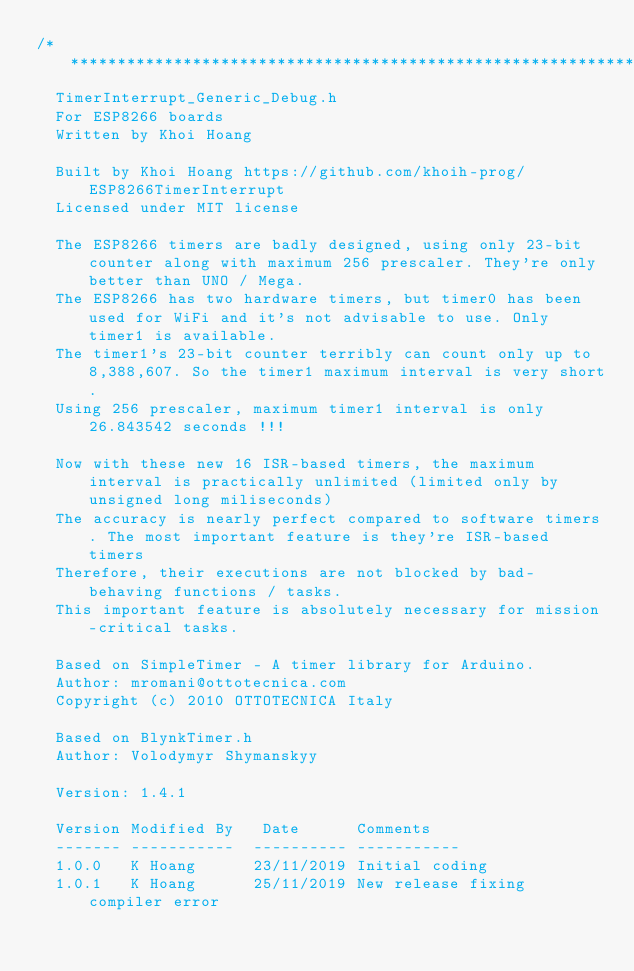Convert code to text. <code><loc_0><loc_0><loc_500><loc_500><_C_>/****************************************************************************************************************************
  TimerInterrupt_Generic_Debug.h
  For ESP8266 boards
  Written by Khoi Hoang

  Built by Khoi Hoang https://github.com/khoih-prog/ESP8266TimerInterrupt
  Licensed under MIT license

  The ESP8266 timers are badly designed, using only 23-bit counter along with maximum 256 prescaler. They're only better than UNO / Mega.
  The ESP8266 has two hardware timers, but timer0 has been used for WiFi and it's not advisable to use. Only timer1 is available.
  The timer1's 23-bit counter terribly can count only up to 8,388,607. So the timer1 maximum interval is very short.
  Using 256 prescaler, maximum timer1 interval is only 26.843542 seconds !!!

  Now with these new 16 ISR-based timers, the maximum interval is practically unlimited (limited only by unsigned long miliseconds)
  The accuracy is nearly perfect compared to software timers. The most important feature is they're ISR-based timers
  Therefore, their executions are not blocked by bad-behaving functions / tasks.
  This important feature is absolutely necessary for mission-critical tasks.

  Based on SimpleTimer - A timer library for Arduino.
  Author: mromani@ottotecnica.com
  Copyright (c) 2010 OTTOTECNICA Italy

  Based on BlynkTimer.h
  Author: Volodymyr Shymanskyy

  Version: 1.4.1

  Version Modified By   Date      Comments
  ------- -----------  ---------- -----------
  1.0.0   K Hoang      23/11/2019 Initial coding
  1.0.1   K Hoang      25/11/2019 New release fixing compiler error</code> 